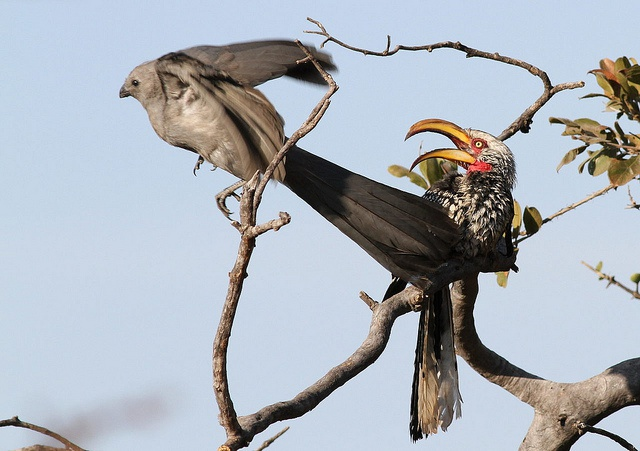Describe the objects in this image and their specific colors. I can see a bird in lightblue, black, gray, and tan tones in this image. 